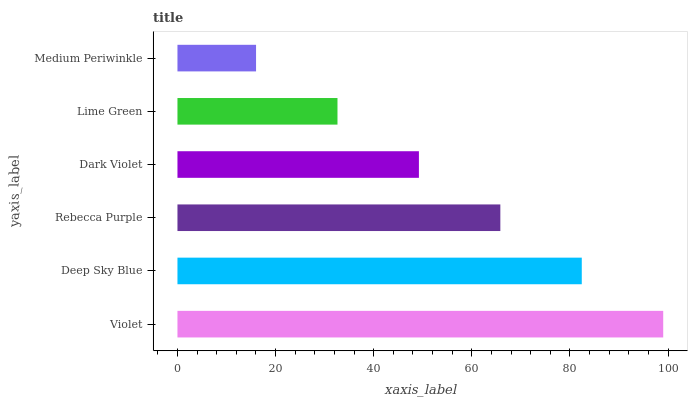Is Medium Periwinkle the minimum?
Answer yes or no. Yes. Is Violet the maximum?
Answer yes or no. Yes. Is Deep Sky Blue the minimum?
Answer yes or no. No. Is Deep Sky Blue the maximum?
Answer yes or no. No. Is Violet greater than Deep Sky Blue?
Answer yes or no. Yes. Is Deep Sky Blue less than Violet?
Answer yes or no. Yes. Is Deep Sky Blue greater than Violet?
Answer yes or no. No. Is Violet less than Deep Sky Blue?
Answer yes or no. No. Is Rebecca Purple the high median?
Answer yes or no. Yes. Is Dark Violet the low median?
Answer yes or no. Yes. Is Lime Green the high median?
Answer yes or no. No. Is Deep Sky Blue the low median?
Answer yes or no. No. 